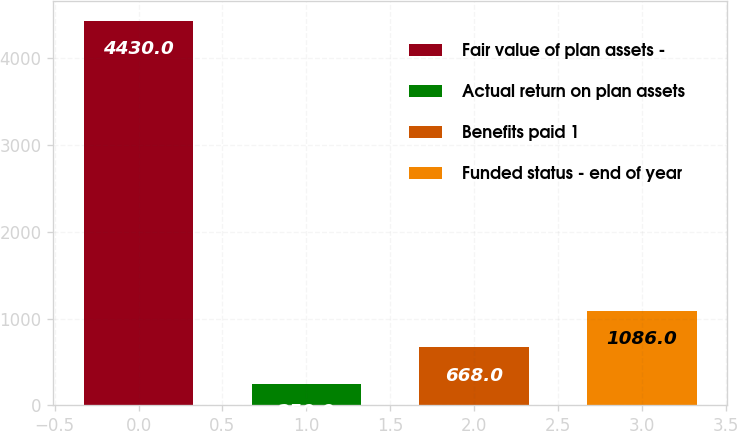Convert chart to OTSL. <chart><loc_0><loc_0><loc_500><loc_500><bar_chart><fcel>Fair value of plan assets -<fcel>Actual return on plan assets<fcel>Benefits paid 1<fcel>Funded status - end of year<nl><fcel>4430<fcel>250<fcel>668<fcel>1086<nl></chart> 